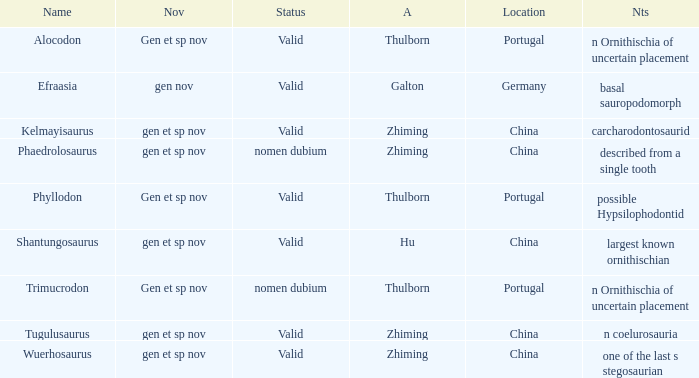What is the Name of the dinosaur that was discovered in the Location, China, and whose Notes are, "described from a single tooth"? Phaedrolosaurus. 